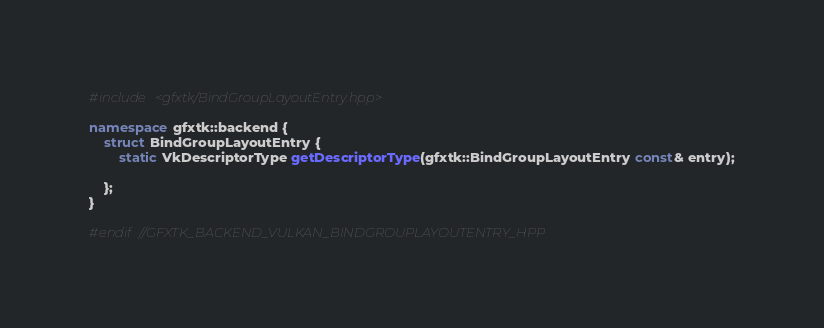<code> <loc_0><loc_0><loc_500><loc_500><_C++_>#include <gfxtk/BindGroupLayoutEntry.hpp>

namespace gfxtk::backend {
    struct BindGroupLayoutEntry {
        static VkDescriptorType getDescriptorType(gfxtk::BindGroupLayoutEntry const& entry);

    };
}

#endif //GFXTK_BACKEND_VULKAN_BINDGROUPLAYOUTENTRY_HPP
</code> 